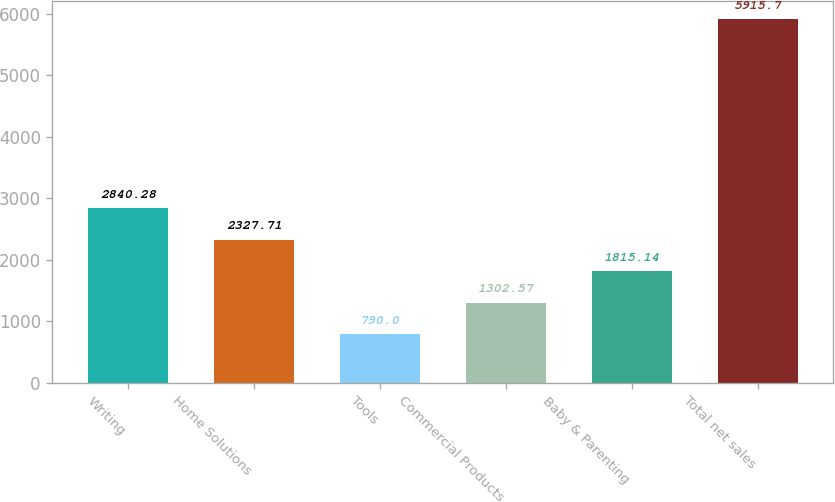Convert chart. <chart><loc_0><loc_0><loc_500><loc_500><bar_chart><fcel>Writing<fcel>Home Solutions<fcel>Tools<fcel>Commercial Products<fcel>Baby & Parenting<fcel>Total net sales<nl><fcel>2840.28<fcel>2327.71<fcel>790<fcel>1302.57<fcel>1815.14<fcel>5915.7<nl></chart> 